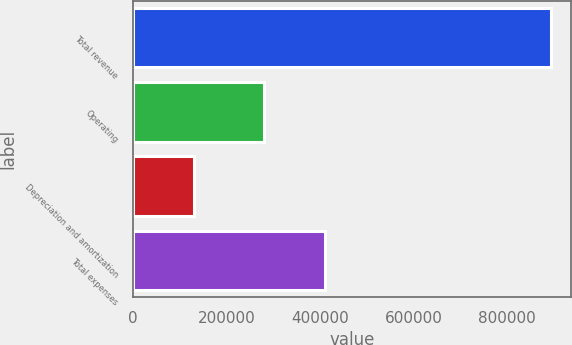Convert chart to OTSL. <chart><loc_0><loc_0><loc_500><loc_500><bar_chart><fcel>Total revenue<fcel>Operating<fcel>Depreciation and amortization<fcel>Total expenses<nl><fcel>892466<fcel>279234<fcel>130998<fcel>410232<nl></chart> 